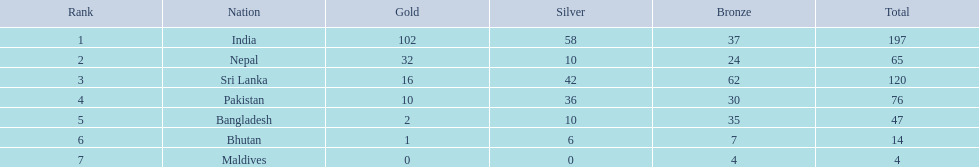What are the overall counts of medals obtained in each country? 197, 65, 120, 76, 47, 14, 4. Which of these counts are below 10? 4. Who earned this amount of medals? Maldives. 